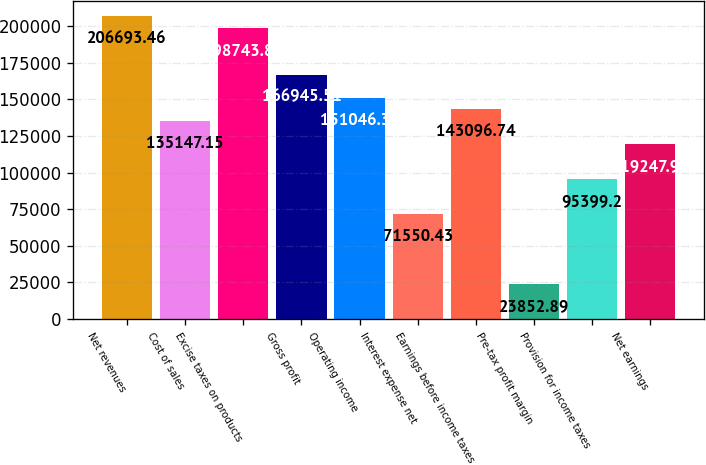<chart> <loc_0><loc_0><loc_500><loc_500><bar_chart><fcel>Net revenues<fcel>Cost of sales<fcel>Excise taxes on products<fcel>Gross profit<fcel>Operating income<fcel>Interest expense net<fcel>Earnings before income taxes<fcel>Pre-tax profit margin<fcel>Provision for income taxes<fcel>Net earnings<nl><fcel>206693<fcel>135147<fcel>198744<fcel>166946<fcel>151046<fcel>71550.4<fcel>143097<fcel>23852.9<fcel>95399.2<fcel>119248<nl></chart> 